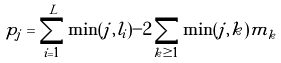<formula> <loc_0><loc_0><loc_500><loc_500>p _ { j } = \sum _ { i = 1 } ^ { L } \min ( j , l _ { i } ) - 2 \sum _ { k \geq 1 } \min ( j , k ) m _ { k }</formula> 